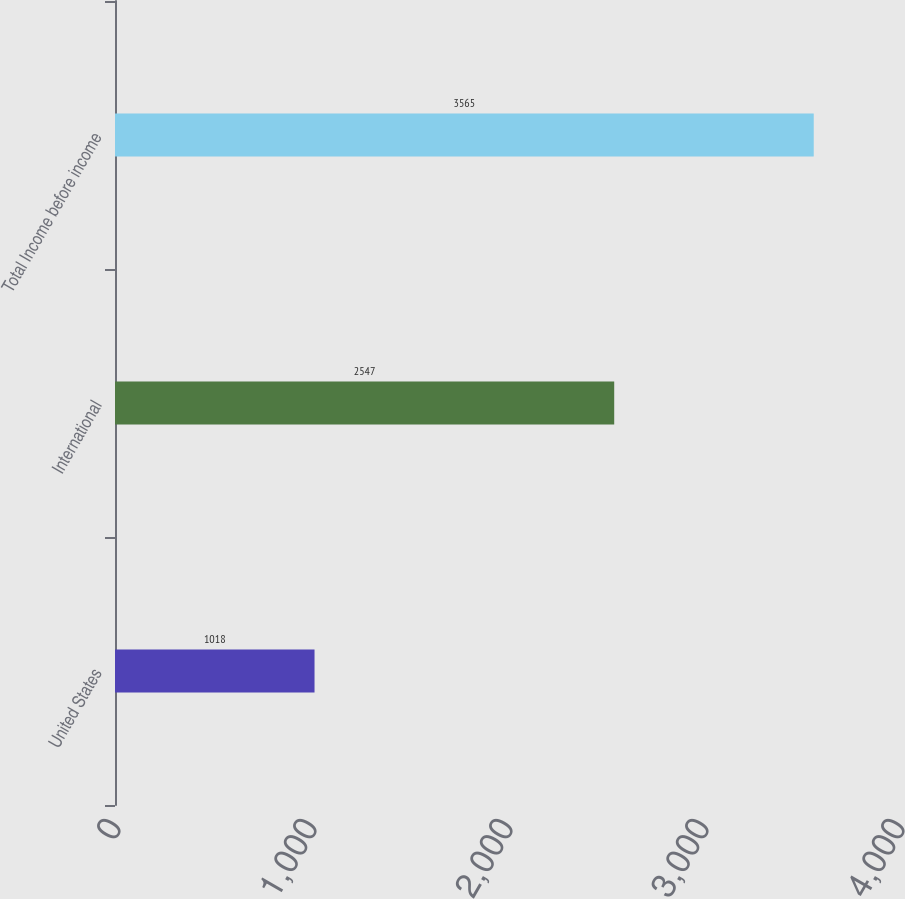Convert chart to OTSL. <chart><loc_0><loc_0><loc_500><loc_500><bar_chart><fcel>United States<fcel>International<fcel>Total Income before income<nl><fcel>1018<fcel>2547<fcel>3565<nl></chart> 